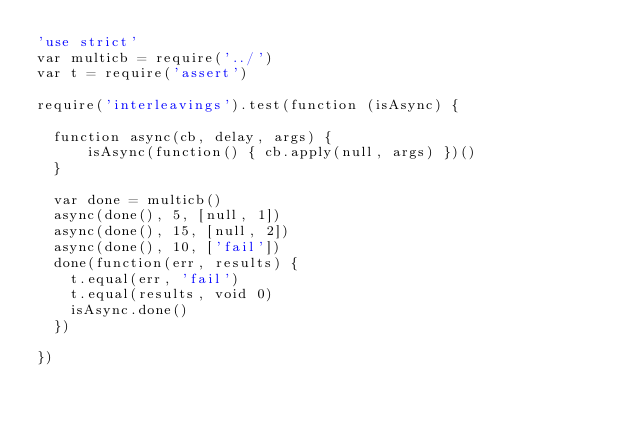Convert code to text. <code><loc_0><loc_0><loc_500><loc_500><_JavaScript_>'use strict'
var multicb = require('../')
var t = require('assert')

require('interleavings').test(function (isAsync) {

  function async(cb, delay, args) {
      isAsync(function() { cb.apply(null, args) })()
  }

  var done = multicb()
  async(done(), 5, [null, 1])
  async(done(), 15, [null, 2])
  async(done(), 10, ['fail'])
  done(function(err, results) {
    t.equal(err, 'fail')
    t.equal(results, void 0)
    isAsync.done()
  })

})
</code> 